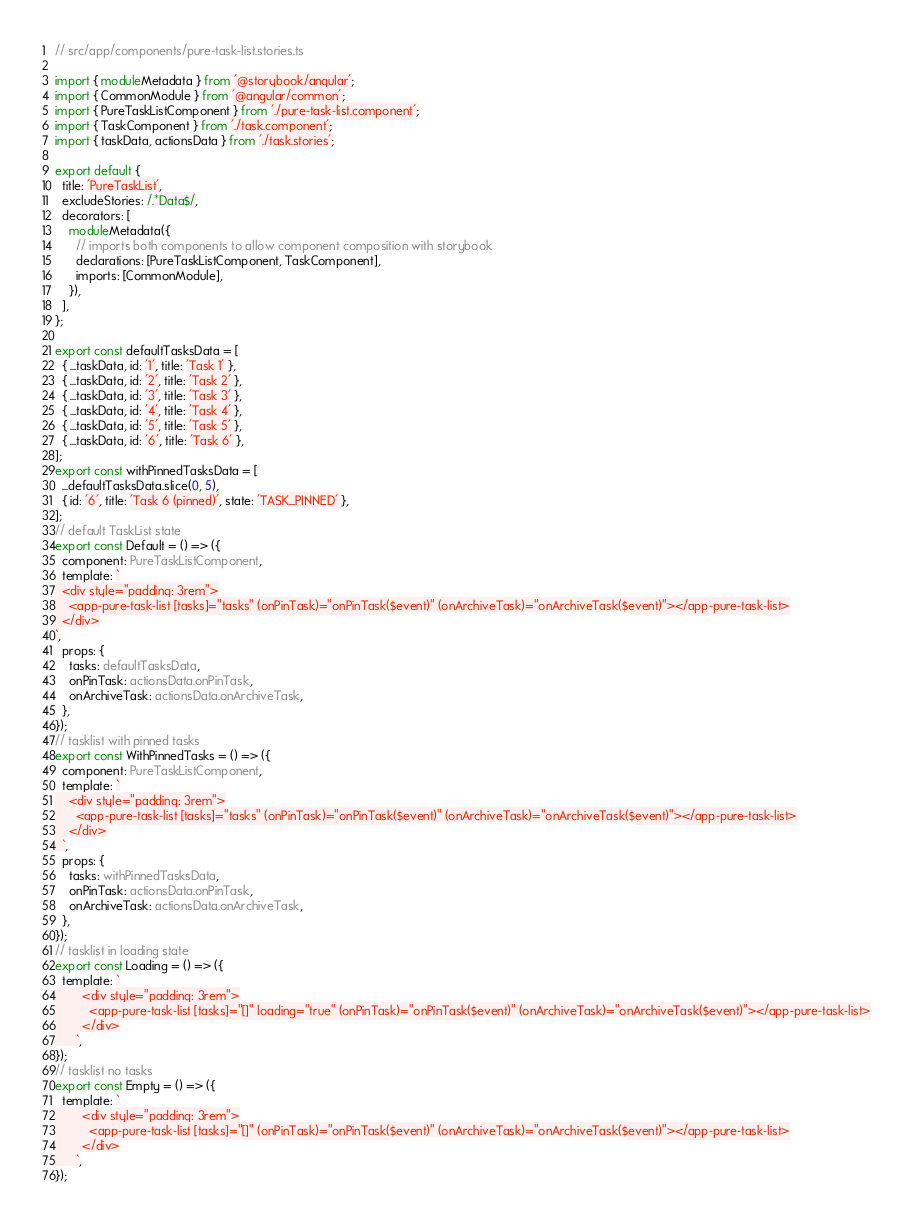Convert code to text. <code><loc_0><loc_0><loc_500><loc_500><_TypeScript_>// src/app/components/pure-task-list.stories.ts

import { moduleMetadata } from '@storybook/angular';
import { CommonModule } from '@angular/common';
import { PureTaskListComponent } from './pure-task-list.component';
import { TaskComponent } from './task.component';
import { taskData, actionsData } from './task.stories';

export default {
  title: 'PureTaskList',
  excludeStories: /.*Data$/,
  decorators: [
    moduleMetadata({
      // imports both components to allow component composition with storybook
      declarations: [PureTaskListComponent, TaskComponent],
      imports: [CommonModule],
    }),
  ],
};

export const defaultTasksData = [
  { ...taskData, id: '1', title: 'Task 1' },
  { ...taskData, id: '2', title: 'Task 2' },
  { ...taskData, id: '3', title: 'Task 3' },
  { ...taskData, id: '4', title: 'Task 4' },
  { ...taskData, id: '5', title: 'Task 5' },
  { ...taskData, id: '6', title: 'Task 6' },
];
export const withPinnedTasksData = [
  ...defaultTasksData.slice(0, 5),
  { id: '6', title: 'Task 6 (pinned)', state: 'TASK_PINNED' },
];
// default TaskList state
export const Default = () => ({
  component: PureTaskListComponent,
  template: `
  <div style="padding: 3rem">
    <app-pure-task-list [tasks]="tasks" (onPinTask)="onPinTask($event)" (onArchiveTask)="onArchiveTask($event)"></app-pure-task-list>
  </div>
`,
  props: {
    tasks: defaultTasksData,
    onPinTask: actionsData.onPinTask,
    onArchiveTask: actionsData.onArchiveTask,
  },
});
// tasklist with pinned tasks
export const WithPinnedTasks = () => ({
  component: PureTaskListComponent,
  template: `
    <div style="padding: 3rem">
      <app-pure-task-list [tasks]="tasks" (onPinTask)="onPinTask($event)" (onArchiveTask)="onArchiveTask($event)"></app-pure-task-list>
    </div>
  `,
  props: {
    tasks: withPinnedTasksData,
    onPinTask: actionsData.onPinTask,
    onArchiveTask: actionsData.onArchiveTask,
  },
});
// tasklist in loading state
export const Loading = () => ({
  template: `
        <div style="padding: 3rem">
          <app-pure-task-list [tasks]="[]" loading="true" (onPinTask)="onPinTask($event)" (onArchiveTask)="onArchiveTask($event)"></app-pure-task-list>
        </div>
      `,
});
// tasklist no tasks
export const Empty = () => ({
  template: `
        <div style="padding: 3rem">
          <app-pure-task-list [tasks]="[]" (onPinTask)="onPinTask($event)" (onArchiveTask)="onArchiveTask($event)"></app-pure-task-list>
        </div>
      `,
});
</code> 